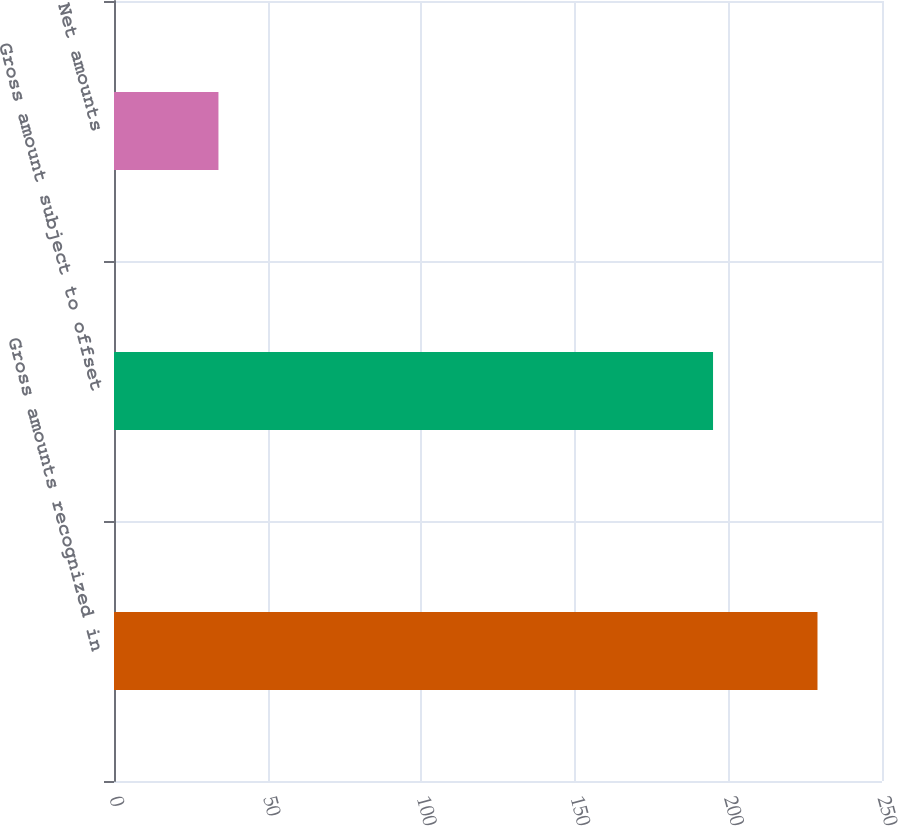Convert chart. <chart><loc_0><loc_0><loc_500><loc_500><bar_chart><fcel>Gross amounts recognized in<fcel>Gross amount subject to offset<fcel>Net amounts<nl><fcel>229<fcel>195<fcel>34<nl></chart> 